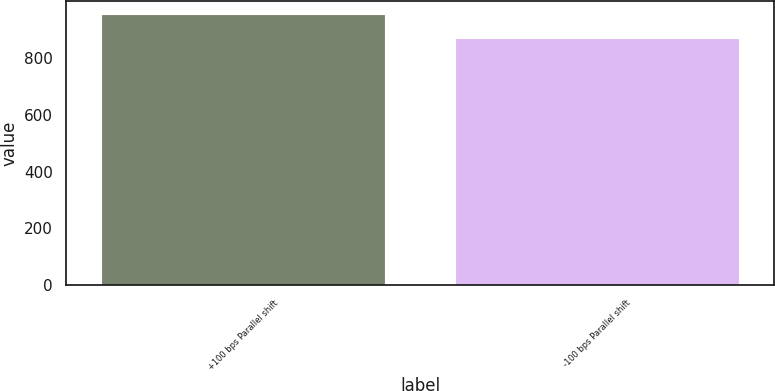Convert chart. <chart><loc_0><loc_0><loc_500><loc_500><bar_chart><fcel>+100 bps Parallel shift<fcel>-100 bps Parallel shift<nl><fcel>952<fcel>865<nl></chart> 